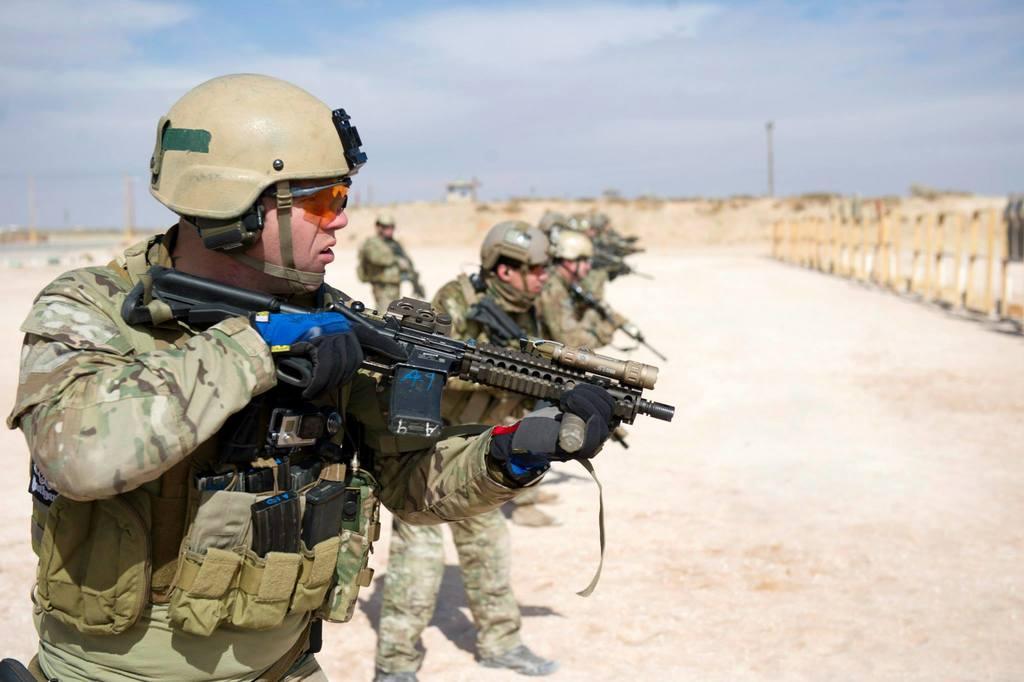Describe this image in one or two sentences. This picture is taken from outside of the city. In this image, on the left side, we can see a group of people standing on the land and holding guns in their hands. On the right side, we can also see a dot. In the background, we can see some poles, building, trees. At the top, we can see a sky which is a bit cloudy, at the bottom, we can see a land with some stones. 